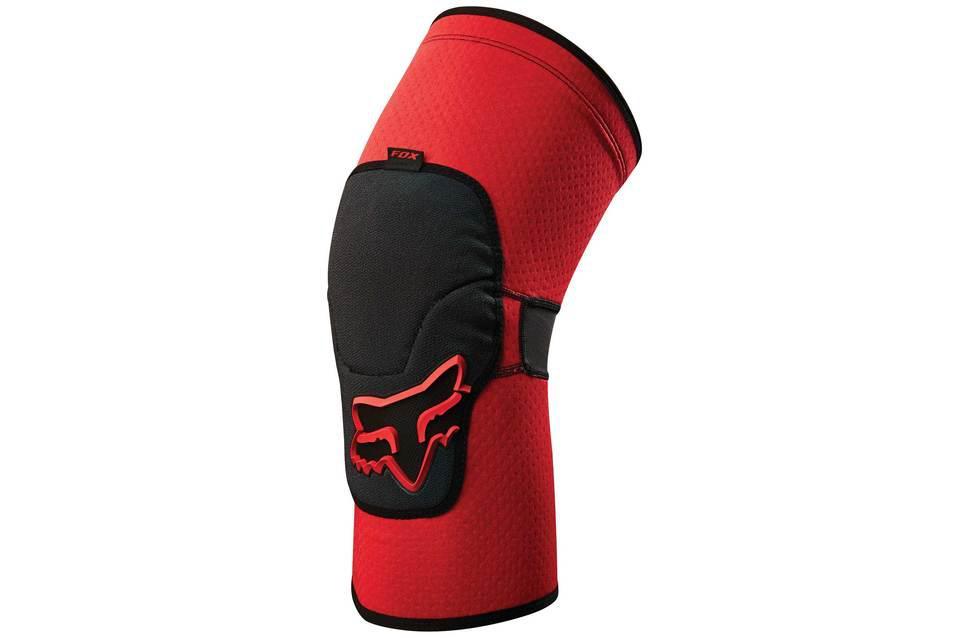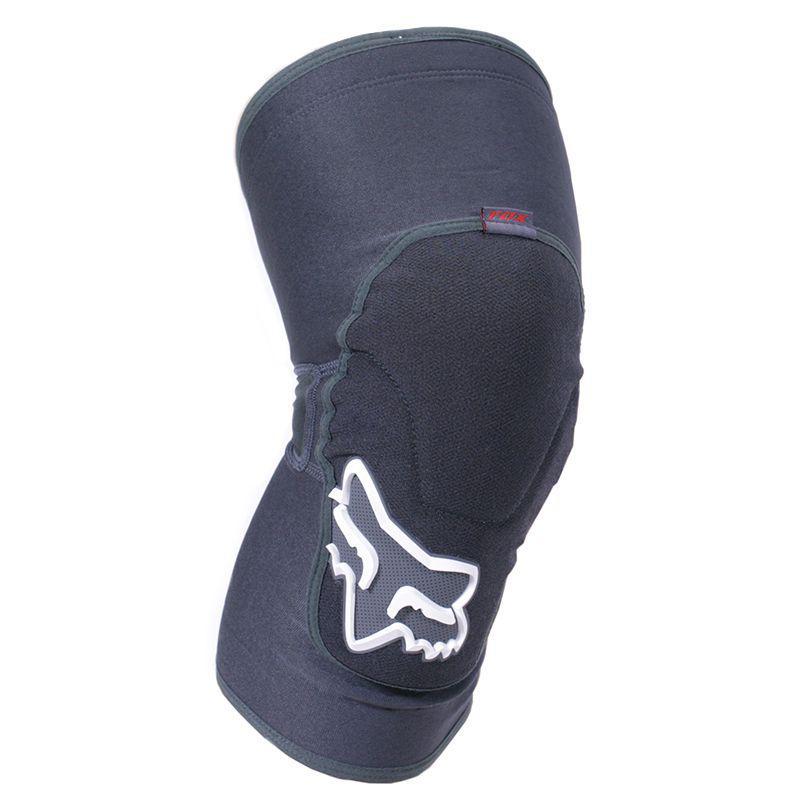The first image is the image on the left, the second image is the image on the right. For the images shown, is this caption "both knee pads are black and shown unworn" true? Answer yes or no. No. 